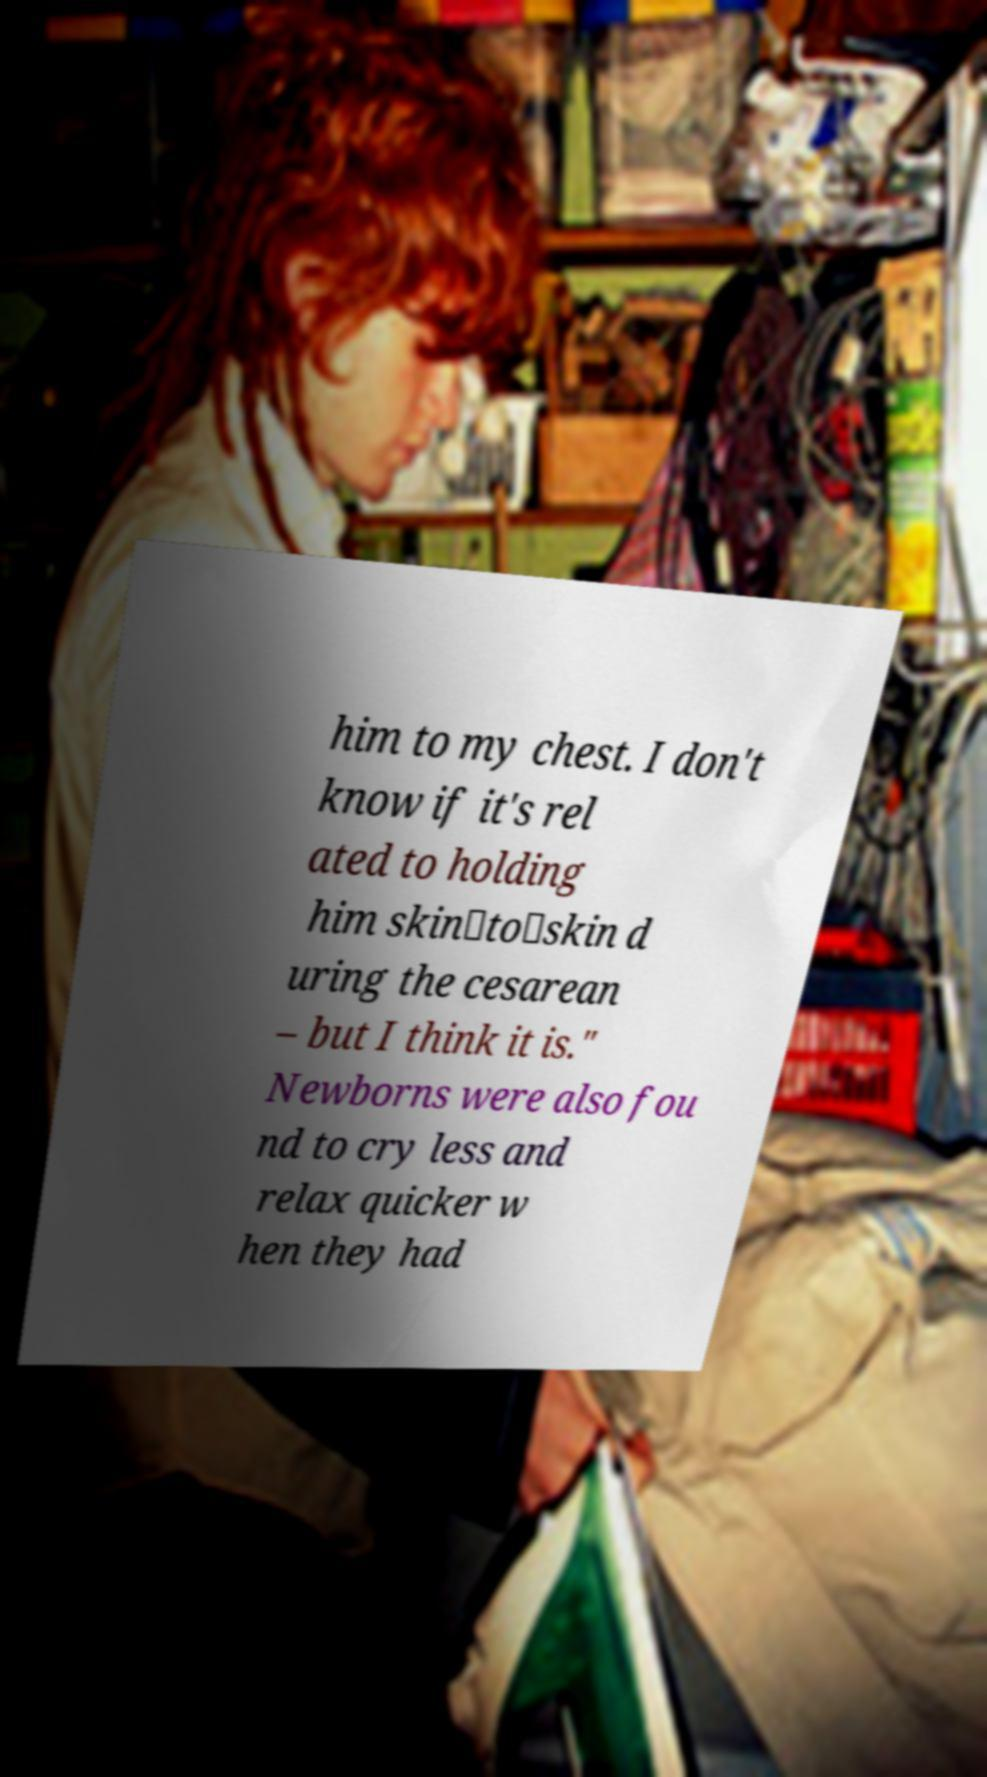What messages or text are displayed in this image? I need them in a readable, typed format. him to my chest. I don't know if it's rel ated to holding him skin‐to‐skin d uring the cesarean – but I think it is." Newborns were also fou nd to cry less and relax quicker w hen they had 